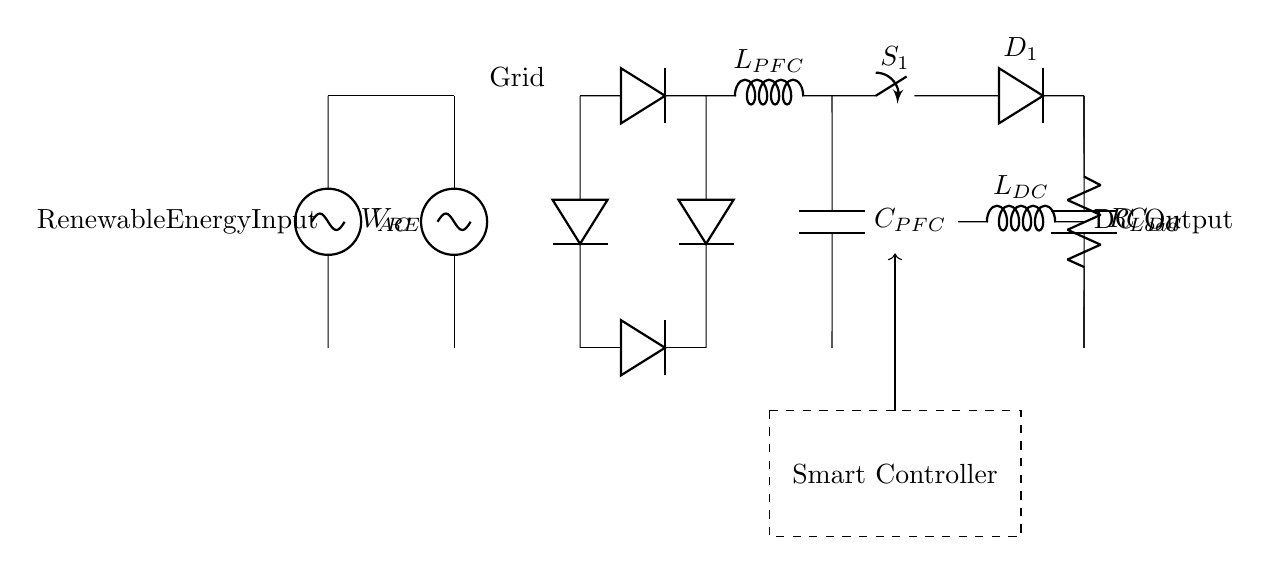What type of rectifier is used in this circuit? The diagram shows a bridge rectifier, which consists of four diodes arranged to convert AC to DC. This configuration allows for both halves of the AC waveform to be used.
Answer: Bridge rectifier What is the role of the inductor labeled L PFC? The inductor labeled L PFC is used for power factor correction, which helps improve the efficiency of the circuit by compensating for the phase difference between voltage and current.
Answer: Power factor correction How many diodes are present in this circuit? There are four diodes visible in the circuit. They are used in the bridge rectifier arrangement to ensure that both halves of the AC signal are converted to DC.
Answer: Four What is the purpose of the capacitor labeled C PFC? The capacitor C PFC is used to smooth out the output signal after rectification, filtering the voltage to ensure a more constant DC output, thus improving the quality of the power delivered to the load.
Answer: Smoothing What is the primary function of the smart controller in the circuit? The smart controller manages the operation of the rectifier and the power factor correction components, optimizing performance based on the input from the renewable energy source and the load demands.
Answer: Performance management What type of load is connected in this circuit? The load is represented by a resistor, indicating a resistive load. This type of load is typical for circuits converting DC power for practical applications.
Answer: Resistor 